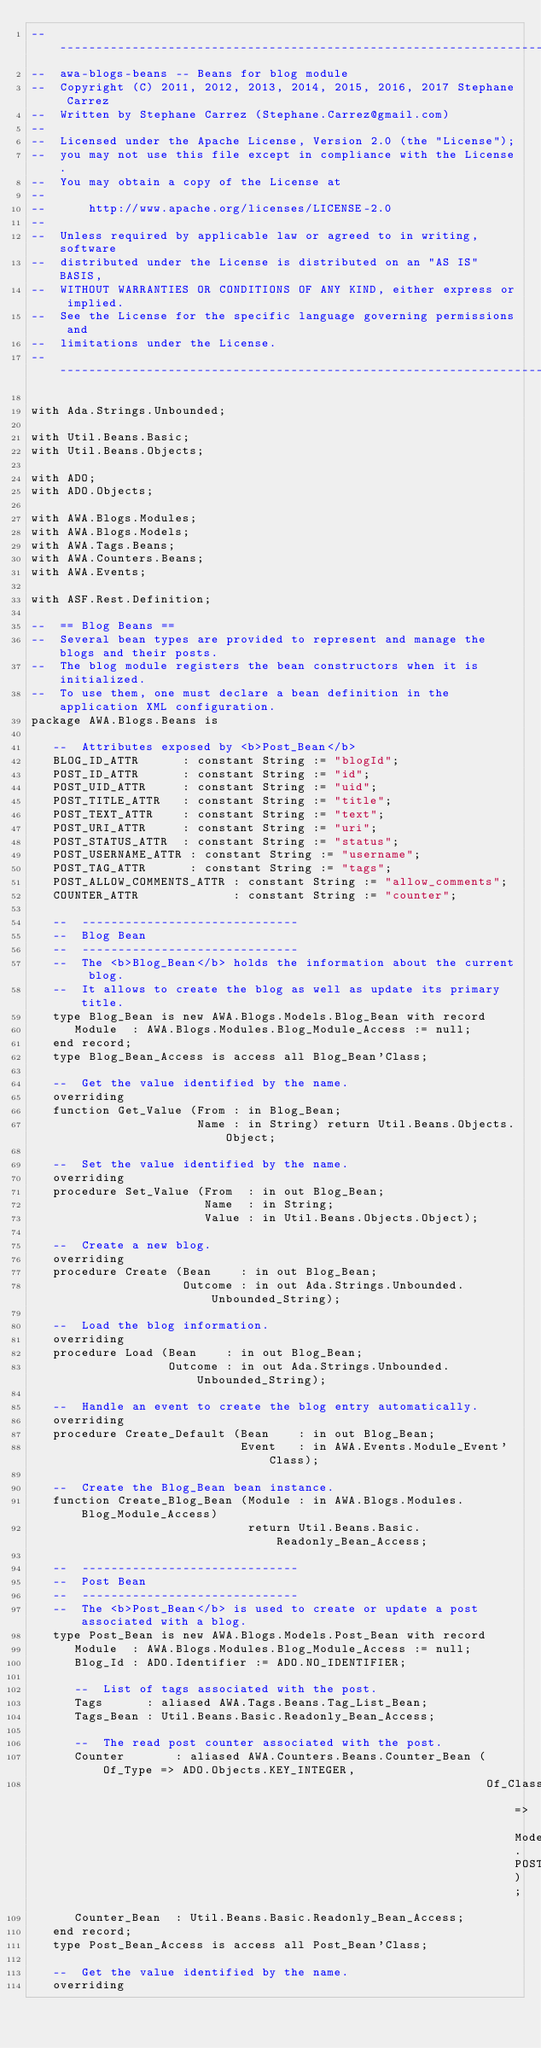Convert code to text. <code><loc_0><loc_0><loc_500><loc_500><_Ada_>-----------------------------------------------------------------------
--  awa-blogs-beans -- Beans for blog module
--  Copyright (C) 2011, 2012, 2013, 2014, 2015, 2016, 2017 Stephane Carrez
--  Written by Stephane Carrez (Stephane.Carrez@gmail.com)
--
--  Licensed under the Apache License, Version 2.0 (the "License");
--  you may not use this file except in compliance with the License.
--  You may obtain a copy of the License at
--
--      http://www.apache.org/licenses/LICENSE-2.0
--
--  Unless required by applicable law or agreed to in writing, software
--  distributed under the License is distributed on an "AS IS" BASIS,
--  WITHOUT WARRANTIES OR CONDITIONS OF ANY KIND, either express or implied.
--  See the License for the specific language governing permissions and
--  limitations under the License.
-----------------------------------------------------------------------

with Ada.Strings.Unbounded;

with Util.Beans.Basic;
with Util.Beans.Objects;

with ADO;
with ADO.Objects;

with AWA.Blogs.Modules;
with AWA.Blogs.Models;
with AWA.Tags.Beans;
with AWA.Counters.Beans;
with AWA.Events;

with ASF.Rest.Definition;

--  == Blog Beans ==
--  Several bean types are provided to represent and manage the blogs and their posts.
--  The blog module registers the bean constructors when it is initialized.
--  To use them, one must declare a bean definition in the application XML configuration.
package AWA.Blogs.Beans is

   --  Attributes exposed by <b>Post_Bean</b>
   BLOG_ID_ATTR      : constant String := "blogId";
   POST_ID_ATTR      : constant String := "id";
   POST_UID_ATTR     : constant String := "uid";
   POST_TITLE_ATTR   : constant String := "title";
   POST_TEXT_ATTR    : constant String := "text";
   POST_URI_ATTR     : constant String := "uri";
   POST_STATUS_ATTR  : constant String := "status";
   POST_USERNAME_ATTR : constant String := "username";
   POST_TAG_ATTR      : constant String := "tags";
   POST_ALLOW_COMMENTS_ATTR : constant String := "allow_comments";
   COUNTER_ATTR             : constant String := "counter";

   --  ------------------------------
   --  Blog Bean
   --  ------------------------------
   --  The <b>Blog_Bean</b> holds the information about the current blog.
   --  It allows to create the blog as well as update its primary title.
   type Blog_Bean is new AWA.Blogs.Models.Blog_Bean with record
      Module  : AWA.Blogs.Modules.Blog_Module_Access := null;
   end record;
   type Blog_Bean_Access is access all Blog_Bean'Class;

   --  Get the value identified by the name.
   overriding
   function Get_Value (From : in Blog_Bean;
                       Name : in String) return Util.Beans.Objects.Object;

   --  Set the value identified by the name.
   overriding
   procedure Set_Value (From  : in out Blog_Bean;
                        Name  : in String;
                        Value : in Util.Beans.Objects.Object);

   --  Create a new blog.
   overriding
   procedure Create (Bean    : in out Blog_Bean;
                     Outcome : in out Ada.Strings.Unbounded.Unbounded_String);

   --  Load the blog information.
   overriding
   procedure Load (Bean    : in out Blog_Bean;
                   Outcome : in out Ada.Strings.Unbounded.Unbounded_String);

   --  Handle an event to create the blog entry automatically.
   overriding
   procedure Create_Default (Bean    : in out Blog_Bean;
                             Event   : in AWA.Events.Module_Event'Class);

   --  Create the Blog_Bean bean instance.
   function Create_Blog_Bean (Module : in AWA.Blogs.Modules.Blog_Module_Access)
                              return Util.Beans.Basic.Readonly_Bean_Access;

   --  ------------------------------
   --  Post Bean
   --  ------------------------------
   --  The <b>Post_Bean</b> is used to create or update a post associated with a blog.
   type Post_Bean is new AWA.Blogs.Models.Post_Bean with record
      Module  : AWA.Blogs.Modules.Blog_Module_Access := null;
      Blog_Id : ADO.Identifier := ADO.NO_IDENTIFIER;

      --  List of tags associated with the post.
      Tags      : aliased AWA.Tags.Beans.Tag_List_Bean;
      Tags_Bean : Util.Beans.Basic.Readonly_Bean_Access;

      --  The read post counter associated with the post.
      Counter       : aliased AWA.Counters.Beans.Counter_Bean (Of_Type => ADO.Objects.KEY_INTEGER,
                                                               Of_Class => Models.POST_TABLE);
      Counter_Bean  : Util.Beans.Basic.Readonly_Bean_Access;
   end record;
   type Post_Bean_Access is access all Post_Bean'Class;

   --  Get the value identified by the name.
   overriding</code> 